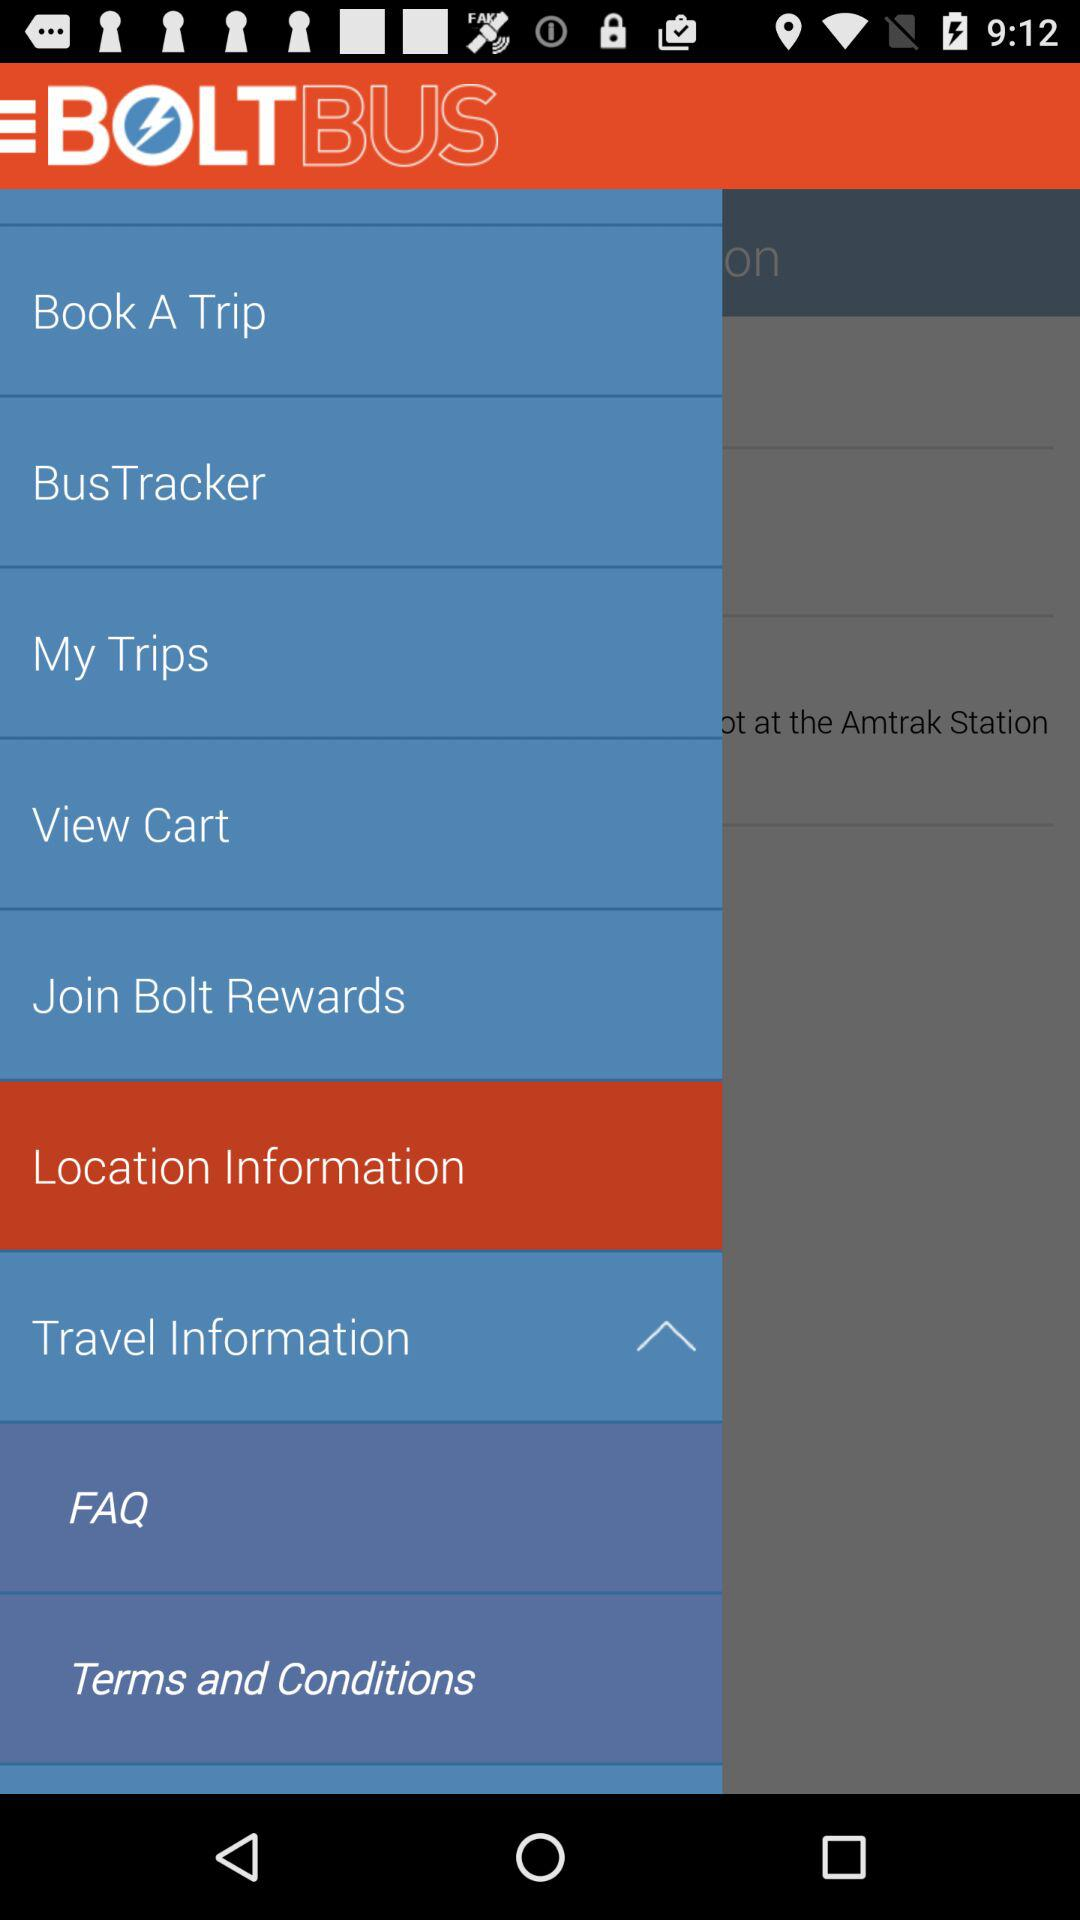What is the application name? The application name is "BOLT BUS". 